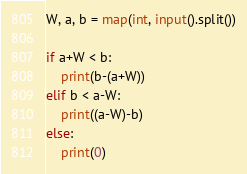Convert code to text. <code><loc_0><loc_0><loc_500><loc_500><_Python_>W, a, b = map(int, input().split())

if a+W < b:
    print(b-(a+W))
elif b < a-W:
    print((a-W)-b)
else:
    print(0)
</code> 